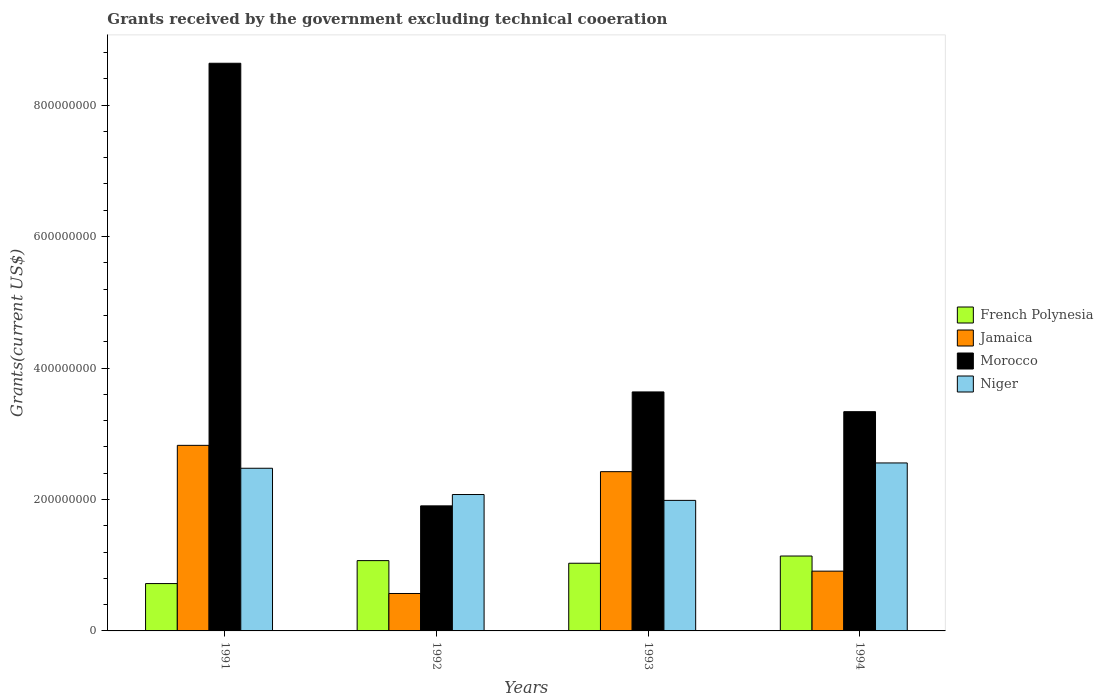How many different coloured bars are there?
Your answer should be compact. 4. How many groups of bars are there?
Offer a terse response. 4. Are the number of bars per tick equal to the number of legend labels?
Your response must be concise. Yes. How many bars are there on the 3rd tick from the right?
Ensure brevity in your answer.  4. What is the label of the 1st group of bars from the left?
Provide a succinct answer. 1991. In how many cases, is the number of bars for a given year not equal to the number of legend labels?
Your response must be concise. 0. What is the total grants received by the government in Niger in 1994?
Your response must be concise. 2.56e+08. Across all years, what is the maximum total grants received by the government in Jamaica?
Give a very brief answer. 2.82e+08. Across all years, what is the minimum total grants received by the government in French Polynesia?
Provide a short and direct response. 7.20e+07. In which year was the total grants received by the government in French Polynesia maximum?
Make the answer very short. 1994. What is the total total grants received by the government in Morocco in the graph?
Your answer should be compact. 1.75e+09. What is the difference between the total grants received by the government in French Polynesia in 1992 and that in 1994?
Your answer should be compact. -6.98e+06. What is the difference between the total grants received by the government in Morocco in 1992 and the total grants received by the government in Niger in 1993?
Your answer should be very brief. -8.35e+06. What is the average total grants received by the government in Niger per year?
Keep it short and to the point. 2.27e+08. In the year 1991, what is the difference between the total grants received by the government in French Polynesia and total grants received by the government in Morocco?
Your answer should be very brief. -7.92e+08. What is the ratio of the total grants received by the government in Niger in 1992 to that in 1994?
Offer a very short reply. 0.81. Is the difference between the total grants received by the government in French Polynesia in 1992 and 1994 greater than the difference between the total grants received by the government in Morocco in 1992 and 1994?
Make the answer very short. Yes. What is the difference between the highest and the second highest total grants received by the government in Niger?
Your answer should be very brief. 8.07e+06. What is the difference between the highest and the lowest total grants received by the government in Niger?
Make the answer very short. 5.70e+07. In how many years, is the total grants received by the government in Niger greater than the average total grants received by the government in Niger taken over all years?
Provide a succinct answer. 2. What does the 1st bar from the left in 1993 represents?
Make the answer very short. French Polynesia. What does the 3rd bar from the right in 1993 represents?
Offer a terse response. Jamaica. How many bars are there?
Ensure brevity in your answer.  16. Are all the bars in the graph horizontal?
Provide a succinct answer. No. How are the legend labels stacked?
Keep it short and to the point. Vertical. What is the title of the graph?
Give a very brief answer. Grants received by the government excluding technical cooeration. What is the label or title of the Y-axis?
Your answer should be compact. Grants(current US$). What is the Grants(current US$) in French Polynesia in 1991?
Provide a short and direct response. 7.20e+07. What is the Grants(current US$) in Jamaica in 1991?
Offer a terse response. 2.82e+08. What is the Grants(current US$) of Morocco in 1991?
Your answer should be very brief. 8.64e+08. What is the Grants(current US$) in Niger in 1991?
Provide a succinct answer. 2.47e+08. What is the Grants(current US$) of French Polynesia in 1992?
Give a very brief answer. 1.07e+08. What is the Grants(current US$) in Jamaica in 1992?
Your answer should be compact. 5.69e+07. What is the Grants(current US$) in Morocco in 1992?
Make the answer very short. 1.90e+08. What is the Grants(current US$) in Niger in 1992?
Provide a short and direct response. 2.08e+08. What is the Grants(current US$) in French Polynesia in 1993?
Give a very brief answer. 1.03e+08. What is the Grants(current US$) in Jamaica in 1993?
Give a very brief answer. 2.42e+08. What is the Grants(current US$) of Morocco in 1993?
Make the answer very short. 3.64e+08. What is the Grants(current US$) of Niger in 1993?
Your response must be concise. 1.99e+08. What is the Grants(current US$) of French Polynesia in 1994?
Give a very brief answer. 1.14e+08. What is the Grants(current US$) of Jamaica in 1994?
Your answer should be very brief. 9.09e+07. What is the Grants(current US$) in Morocco in 1994?
Provide a short and direct response. 3.34e+08. What is the Grants(current US$) of Niger in 1994?
Provide a short and direct response. 2.56e+08. Across all years, what is the maximum Grants(current US$) of French Polynesia?
Provide a short and direct response. 1.14e+08. Across all years, what is the maximum Grants(current US$) in Jamaica?
Your response must be concise. 2.82e+08. Across all years, what is the maximum Grants(current US$) of Morocco?
Offer a very short reply. 8.64e+08. Across all years, what is the maximum Grants(current US$) in Niger?
Offer a terse response. 2.56e+08. Across all years, what is the minimum Grants(current US$) in French Polynesia?
Give a very brief answer. 7.20e+07. Across all years, what is the minimum Grants(current US$) of Jamaica?
Offer a very short reply. 5.69e+07. Across all years, what is the minimum Grants(current US$) of Morocco?
Your response must be concise. 1.90e+08. Across all years, what is the minimum Grants(current US$) of Niger?
Ensure brevity in your answer.  1.99e+08. What is the total Grants(current US$) of French Polynesia in the graph?
Provide a succinct answer. 3.96e+08. What is the total Grants(current US$) of Jamaica in the graph?
Ensure brevity in your answer.  6.73e+08. What is the total Grants(current US$) in Morocco in the graph?
Keep it short and to the point. 1.75e+09. What is the total Grants(current US$) in Niger in the graph?
Ensure brevity in your answer.  9.09e+08. What is the difference between the Grants(current US$) of French Polynesia in 1991 and that in 1992?
Your answer should be very brief. -3.49e+07. What is the difference between the Grants(current US$) in Jamaica in 1991 and that in 1992?
Provide a short and direct response. 2.25e+08. What is the difference between the Grants(current US$) in Morocco in 1991 and that in 1992?
Your answer should be very brief. 6.73e+08. What is the difference between the Grants(current US$) in Niger in 1991 and that in 1992?
Your response must be concise. 4.00e+07. What is the difference between the Grants(current US$) in French Polynesia in 1991 and that in 1993?
Offer a very short reply. -3.09e+07. What is the difference between the Grants(current US$) in Jamaica in 1991 and that in 1993?
Make the answer very short. 4.00e+07. What is the difference between the Grants(current US$) of Morocco in 1991 and that in 1993?
Your answer should be very brief. 5.00e+08. What is the difference between the Grants(current US$) in Niger in 1991 and that in 1993?
Provide a succinct answer. 4.89e+07. What is the difference between the Grants(current US$) in French Polynesia in 1991 and that in 1994?
Make the answer very short. -4.19e+07. What is the difference between the Grants(current US$) in Jamaica in 1991 and that in 1994?
Your answer should be very brief. 1.91e+08. What is the difference between the Grants(current US$) in Morocco in 1991 and that in 1994?
Offer a terse response. 5.30e+08. What is the difference between the Grants(current US$) in Niger in 1991 and that in 1994?
Your answer should be compact. -8.07e+06. What is the difference between the Grants(current US$) in French Polynesia in 1992 and that in 1993?
Offer a very short reply. 4.01e+06. What is the difference between the Grants(current US$) in Jamaica in 1992 and that in 1993?
Offer a terse response. -1.85e+08. What is the difference between the Grants(current US$) in Morocco in 1992 and that in 1993?
Make the answer very short. -1.73e+08. What is the difference between the Grants(current US$) in Niger in 1992 and that in 1993?
Give a very brief answer. 8.92e+06. What is the difference between the Grants(current US$) of French Polynesia in 1992 and that in 1994?
Offer a very short reply. -6.98e+06. What is the difference between the Grants(current US$) of Jamaica in 1992 and that in 1994?
Give a very brief answer. -3.40e+07. What is the difference between the Grants(current US$) of Morocco in 1992 and that in 1994?
Give a very brief answer. -1.43e+08. What is the difference between the Grants(current US$) of Niger in 1992 and that in 1994?
Provide a short and direct response. -4.80e+07. What is the difference between the Grants(current US$) in French Polynesia in 1993 and that in 1994?
Offer a terse response. -1.10e+07. What is the difference between the Grants(current US$) of Jamaica in 1993 and that in 1994?
Provide a short and direct response. 1.51e+08. What is the difference between the Grants(current US$) in Morocco in 1993 and that in 1994?
Offer a terse response. 3.01e+07. What is the difference between the Grants(current US$) of Niger in 1993 and that in 1994?
Your answer should be very brief. -5.70e+07. What is the difference between the Grants(current US$) of French Polynesia in 1991 and the Grants(current US$) of Jamaica in 1992?
Provide a short and direct response. 1.51e+07. What is the difference between the Grants(current US$) of French Polynesia in 1991 and the Grants(current US$) of Morocco in 1992?
Offer a very short reply. -1.18e+08. What is the difference between the Grants(current US$) of French Polynesia in 1991 and the Grants(current US$) of Niger in 1992?
Your response must be concise. -1.36e+08. What is the difference between the Grants(current US$) of Jamaica in 1991 and the Grants(current US$) of Morocco in 1992?
Your answer should be compact. 9.21e+07. What is the difference between the Grants(current US$) in Jamaica in 1991 and the Grants(current US$) in Niger in 1992?
Keep it short and to the point. 7.48e+07. What is the difference between the Grants(current US$) in Morocco in 1991 and the Grants(current US$) in Niger in 1992?
Make the answer very short. 6.56e+08. What is the difference between the Grants(current US$) in French Polynesia in 1991 and the Grants(current US$) in Jamaica in 1993?
Provide a short and direct response. -1.70e+08. What is the difference between the Grants(current US$) of French Polynesia in 1991 and the Grants(current US$) of Morocco in 1993?
Ensure brevity in your answer.  -2.92e+08. What is the difference between the Grants(current US$) of French Polynesia in 1991 and the Grants(current US$) of Niger in 1993?
Your answer should be compact. -1.27e+08. What is the difference between the Grants(current US$) of Jamaica in 1991 and the Grants(current US$) of Morocco in 1993?
Make the answer very short. -8.13e+07. What is the difference between the Grants(current US$) of Jamaica in 1991 and the Grants(current US$) of Niger in 1993?
Make the answer very short. 8.37e+07. What is the difference between the Grants(current US$) in Morocco in 1991 and the Grants(current US$) in Niger in 1993?
Offer a terse response. 6.65e+08. What is the difference between the Grants(current US$) in French Polynesia in 1991 and the Grants(current US$) in Jamaica in 1994?
Your response must be concise. -1.89e+07. What is the difference between the Grants(current US$) of French Polynesia in 1991 and the Grants(current US$) of Morocco in 1994?
Your response must be concise. -2.62e+08. What is the difference between the Grants(current US$) of French Polynesia in 1991 and the Grants(current US$) of Niger in 1994?
Your answer should be compact. -1.84e+08. What is the difference between the Grants(current US$) of Jamaica in 1991 and the Grants(current US$) of Morocco in 1994?
Make the answer very short. -5.12e+07. What is the difference between the Grants(current US$) in Jamaica in 1991 and the Grants(current US$) in Niger in 1994?
Make the answer very short. 2.68e+07. What is the difference between the Grants(current US$) of Morocco in 1991 and the Grants(current US$) of Niger in 1994?
Provide a succinct answer. 6.08e+08. What is the difference between the Grants(current US$) of French Polynesia in 1992 and the Grants(current US$) of Jamaica in 1993?
Keep it short and to the point. -1.35e+08. What is the difference between the Grants(current US$) in French Polynesia in 1992 and the Grants(current US$) in Morocco in 1993?
Offer a terse response. -2.57e+08. What is the difference between the Grants(current US$) in French Polynesia in 1992 and the Grants(current US$) in Niger in 1993?
Provide a short and direct response. -9.16e+07. What is the difference between the Grants(current US$) of Jamaica in 1992 and the Grants(current US$) of Morocco in 1993?
Your response must be concise. -3.07e+08. What is the difference between the Grants(current US$) in Jamaica in 1992 and the Grants(current US$) in Niger in 1993?
Make the answer very short. -1.42e+08. What is the difference between the Grants(current US$) in Morocco in 1992 and the Grants(current US$) in Niger in 1993?
Offer a very short reply. -8.35e+06. What is the difference between the Grants(current US$) of French Polynesia in 1992 and the Grants(current US$) of Jamaica in 1994?
Offer a very short reply. 1.60e+07. What is the difference between the Grants(current US$) of French Polynesia in 1992 and the Grants(current US$) of Morocco in 1994?
Your response must be concise. -2.27e+08. What is the difference between the Grants(current US$) in French Polynesia in 1992 and the Grants(current US$) in Niger in 1994?
Make the answer very short. -1.49e+08. What is the difference between the Grants(current US$) in Jamaica in 1992 and the Grants(current US$) in Morocco in 1994?
Your response must be concise. -2.77e+08. What is the difference between the Grants(current US$) of Jamaica in 1992 and the Grants(current US$) of Niger in 1994?
Provide a succinct answer. -1.99e+08. What is the difference between the Grants(current US$) in Morocco in 1992 and the Grants(current US$) in Niger in 1994?
Keep it short and to the point. -6.53e+07. What is the difference between the Grants(current US$) of French Polynesia in 1993 and the Grants(current US$) of Jamaica in 1994?
Make the answer very short. 1.20e+07. What is the difference between the Grants(current US$) of French Polynesia in 1993 and the Grants(current US$) of Morocco in 1994?
Keep it short and to the point. -2.31e+08. What is the difference between the Grants(current US$) in French Polynesia in 1993 and the Grants(current US$) in Niger in 1994?
Provide a short and direct response. -1.53e+08. What is the difference between the Grants(current US$) in Jamaica in 1993 and the Grants(current US$) in Morocco in 1994?
Give a very brief answer. -9.12e+07. What is the difference between the Grants(current US$) of Jamaica in 1993 and the Grants(current US$) of Niger in 1994?
Keep it short and to the point. -1.33e+07. What is the difference between the Grants(current US$) in Morocco in 1993 and the Grants(current US$) in Niger in 1994?
Give a very brief answer. 1.08e+08. What is the average Grants(current US$) in French Polynesia per year?
Make the answer very short. 9.90e+07. What is the average Grants(current US$) of Jamaica per year?
Your response must be concise. 1.68e+08. What is the average Grants(current US$) in Morocco per year?
Your response must be concise. 4.38e+08. What is the average Grants(current US$) of Niger per year?
Provide a succinct answer. 2.27e+08. In the year 1991, what is the difference between the Grants(current US$) of French Polynesia and Grants(current US$) of Jamaica?
Ensure brevity in your answer.  -2.10e+08. In the year 1991, what is the difference between the Grants(current US$) of French Polynesia and Grants(current US$) of Morocco?
Make the answer very short. -7.92e+08. In the year 1991, what is the difference between the Grants(current US$) in French Polynesia and Grants(current US$) in Niger?
Your response must be concise. -1.75e+08. In the year 1991, what is the difference between the Grants(current US$) of Jamaica and Grants(current US$) of Morocco?
Provide a succinct answer. -5.81e+08. In the year 1991, what is the difference between the Grants(current US$) in Jamaica and Grants(current US$) in Niger?
Provide a succinct answer. 3.48e+07. In the year 1991, what is the difference between the Grants(current US$) in Morocco and Grants(current US$) in Niger?
Your answer should be very brief. 6.16e+08. In the year 1992, what is the difference between the Grants(current US$) in French Polynesia and Grants(current US$) in Jamaica?
Keep it short and to the point. 5.00e+07. In the year 1992, what is the difference between the Grants(current US$) in French Polynesia and Grants(current US$) in Morocco?
Give a very brief answer. -8.33e+07. In the year 1992, what is the difference between the Grants(current US$) of French Polynesia and Grants(current US$) of Niger?
Ensure brevity in your answer.  -1.01e+08. In the year 1992, what is the difference between the Grants(current US$) in Jamaica and Grants(current US$) in Morocco?
Make the answer very short. -1.33e+08. In the year 1992, what is the difference between the Grants(current US$) in Jamaica and Grants(current US$) in Niger?
Give a very brief answer. -1.51e+08. In the year 1992, what is the difference between the Grants(current US$) in Morocco and Grants(current US$) in Niger?
Make the answer very short. -1.73e+07. In the year 1993, what is the difference between the Grants(current US$) in French Polynesia and Grants(current US$) in Jamaica?
Offer a terse response. -1.39e+08. In the year 1993, what is the difference between the Grants(current US$) in French Polynesia and Grants(current US$) in Morocco?
Keep it short and to the point. -2.61e+08. In the year 1993, what is the difference between the Grants(current US$) of French Polynesia and Grants(current US$) of Niger?
Make the answer very short. -9.56e+07. In the year 1993, what is the difference between the Grants(current US$) in Jamaica and Grants(current US$) in Morocco?
Provide a short and direct response. -1.21e+08. In the year 1993, what is the difference between the Grants(current US$) of Jamaica and Grants(current US$) of Niger?
Make the answer very short. 4.37e+07. In the year 1993, what is the difference between the Grants(current US$) of Morocco and Grants(current US$) of Niger?
Your response must be concise. 1.65e+08. In the year 1994, what is the difference between the Grants(current US$) in French Polynesia and Grants(current US$) in Jamaica?
Provide a short and direct response. 2.30e+07. In the year 1994, what is the difference between the Grants(current US$) of French Polynesia and Grants(current US$) of Morocco?
Give a very brief answer. -2.20e+08. In the year 1994, what is the difference between the Grants(current US$) of French Polynesia and Grants(current US$) of Niger?
Your response must be concise. -1.42e+08. In the year 1994, what is the difference between the Grants(current US$) of Jamaica and Grants(current US$) of Morocco?
Give a very brief answer. -2.43e+08. In the year 1994, what is the difference between the Grants(current US$) of Jamaica and Grants(current US$) of Niger?
Provide a succinct answer. -1.65e+08. In the year 1994, what is the difference between the Grants(current US$) of Morocco and Grants(current US$) of Niger?
Your answer should be very brief. 7.80e+07. What is the ratio of the Grants(current US$) of French Polynesia in 1991 to that in 1992?
Make the answer very short. 0.67. What is the ratio of the Grants(current US$) of Jamaica in 1991 to that in 1992?
Ensure brevity in your answer.  4.96. What is the ratio of the Grants(current US$) in Morocco in 1991 to that in 1992?
Offer a very short reply. 4.54. What is the ratio of the Grants(current US$) of Niger in 1991 to that in 1992?
Offer a very short reply. 1.19. What is the ratio of the Grants(current US$) in French Polynesia in 1991 to that in 1993?
Offer a terse response. 0.7. What is the ratio of the Grants(current US$) in Jamaica in 1991 to that in 1993?
Provide a succinct answer. 1.17. What is the ratio of the Grants(current US$) of Morocco in 1991 to that in 1993?
Make the answer very short. 2.38. What is the ratio of the Grants(current US$) of Niger in 1991 to that in 1993?
Ensure brevity in your answer.  1.25. What is the ratio of the Grants(current US$) of French Polynesia in 1991 to that in 1994?
Your answer should be compact. 0.63. What is the ratio of the Grants(current US$) in Jamaica in 1991 to that in 1994?
Offer a terse response. 3.1. What is the ratio of the Grants(current US$) of Morocco in 1991 to that in 1994?
Keep it short and to the point. 2.59. What is the ratio of the Grants(current US$) in Niger in 1991 to that in 1994?
Your answer should be compact. 0.97. What is the ratio of the Grants(current US$) of French Polynesia in 1992 to that in 1993?
Your answer should be very brief. 1.04. What is the ratio of the Grants(current US$) of Jamaica in 1992 to that in 1993?
Your answer should be compact. 0.23. What is the ratio of the Grants(current US$) of Morocco in 1992 to that in 1993?
Offer a very short reply. 0.52. What is the ratio of the Grants(current US$) in Niger in 1992 to that in 1993?
Ensure brevity in your answer.  1.04. What is the ratio of the Grants(current US$) of French Polynesia in 1992 to that in 1994?
Keep it short and to the point. 0.94. What is the ratio of the Grants(current US$) in Jamaica in 1992 to that in 1994?
Provide a short and direct response. 0.63. What is the ratio of the Grants(current US$) of Morocco in 1992 to that in 1994?
Offer a very short reply. 0.57. What is the ratio of the Grants(current US$) in Niger in 1992 to that in 1994?
Keep it short and to the point. 0.81. What is the ratio of the Grants(current US$) of French Polynesia in 1993 to that in 1994?
Give a very brief answer. 0.9. What is the ratio of the Grants(current US$) in Jamaica in 1993 to that in 1994?
Your answer should be compact. 2.66. What is the ratio of the Grants(current US$) in Morocco in 1993 to that in 1994?
Ensure brevity in your answer.  1.09. What is the ratio of the Grants(current US$) of Niger in 1993 to that in 1994?
Make the answer very short. 0.78. What is the difference between the highest and the second highest Grants(current US$) in French Polynesia?
Provide a succinct answer. 6.98e+06. What is the difference between the highest and the second highest Grants(current US$) of Jamaica?
Ensure brevity in your answer.  4.00e+07. What is the difference between the highest and the second highest Grants(current US$) of Morocco?
Offer a very short reply. 5.00e+08. What is the difference between the highest and the second highest Grants(current US$) of Niger?
Offer a very short reply. 8.07e+06. What is the difference between the highest and the lowest Grants(current US$) of French Polynesia?
Give a very brief answer. 4.19e+07. What is the difference between the highest and the lowest Grants(current US$) in Jamaica?
Offer a very short reply. 2.25e+08. What is the difference between the highest and the lowest Grants(current US$) of Morocco?
Provide a succinct answer. 6.73e+08. What is the difference between the highest and the lowest Grants(current US$) of Niger?
Ensure brevity in your answer.  5.70e+07. 